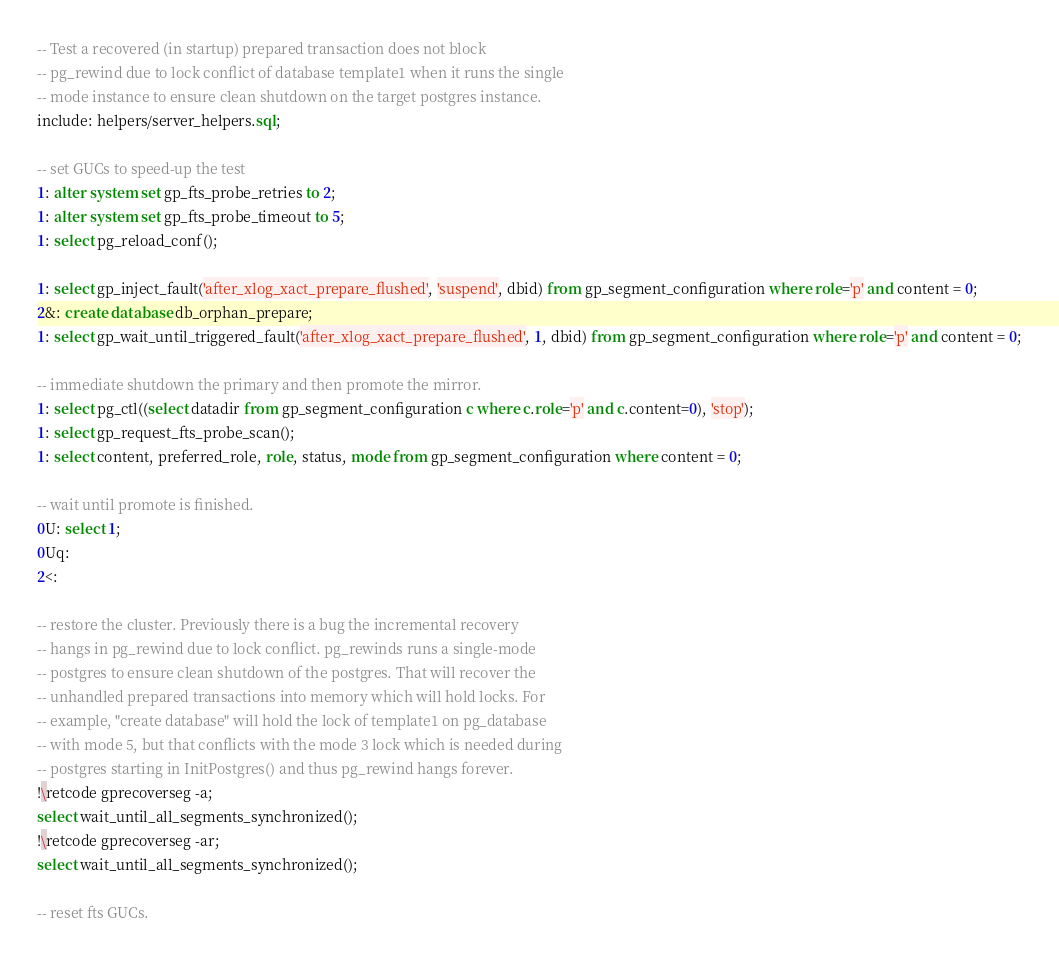<code> <loc_0><loc_0><loc_500><loc_500><_SQL_>-- Test a recovered (in startup) prepared transaction does not block
-- pg_rewind due to lock conflict of database template1 when it runs the single
-- mode instance to ensure clean shutdown on the target postgres instance.
include: helpers/server_helpers.sql;

-- set GUCs to speed-up the test
1: alter system set gp_fts_probe_retries to 2;
1: alter system set gp_fts_probe_timeout to 5;
1: select pg_reload_conf();

1: select gp_inject_fault('after_xlog_xact_prepare_flushed', 'suspend', dbid) from gp_segment_configuration where role='p' and content = 0;
2&: create database db_orphan_prepare;
1: select gp_wait_until_triggered_fault('after_xlog_xact_prepare_flushed', 1, dbid) from gp_segment_configuration where role='p' and content = 0;

-- immediate shutdown the primary and then promote the mirror.
1: select pg_ctl((select datadir from gp_segment_configuration c where c.role='p' and c.content=0), 'stop');
1: select gp_request_fts_probe_scan();
1: select content, preferred_role, role, status, mode from gp_segment_configuration where content = 0;

-- wait until promote is finished.
0U: select 1;
0Uq:
2<:

-- restore the cluster. Previously there is a bug the incremental recovery
-- hangs in pg_rewind due to lock conflict. pg_rewinds runs a single-mode
-- postgres to ensure clean shutdown of the postgres. That will recover the
-- unhandled prepared transactions into memory which will hold locks. For
-- example, "create database" will hold the lock of template1 on pg_database
-- with mode 5, but that conflicts with the mode 3 lock which is needed during
-- postgres starting in InitPostgres() and thus pg_rewind hangs forever.
!\retcode gprecoverseg -a;
select wait_until_all_segments_synchronized();
!\retcode gprecoverseg -ar;
select wait_until_all_segments_synchronized();

-- reset fts GUCs.</code> 